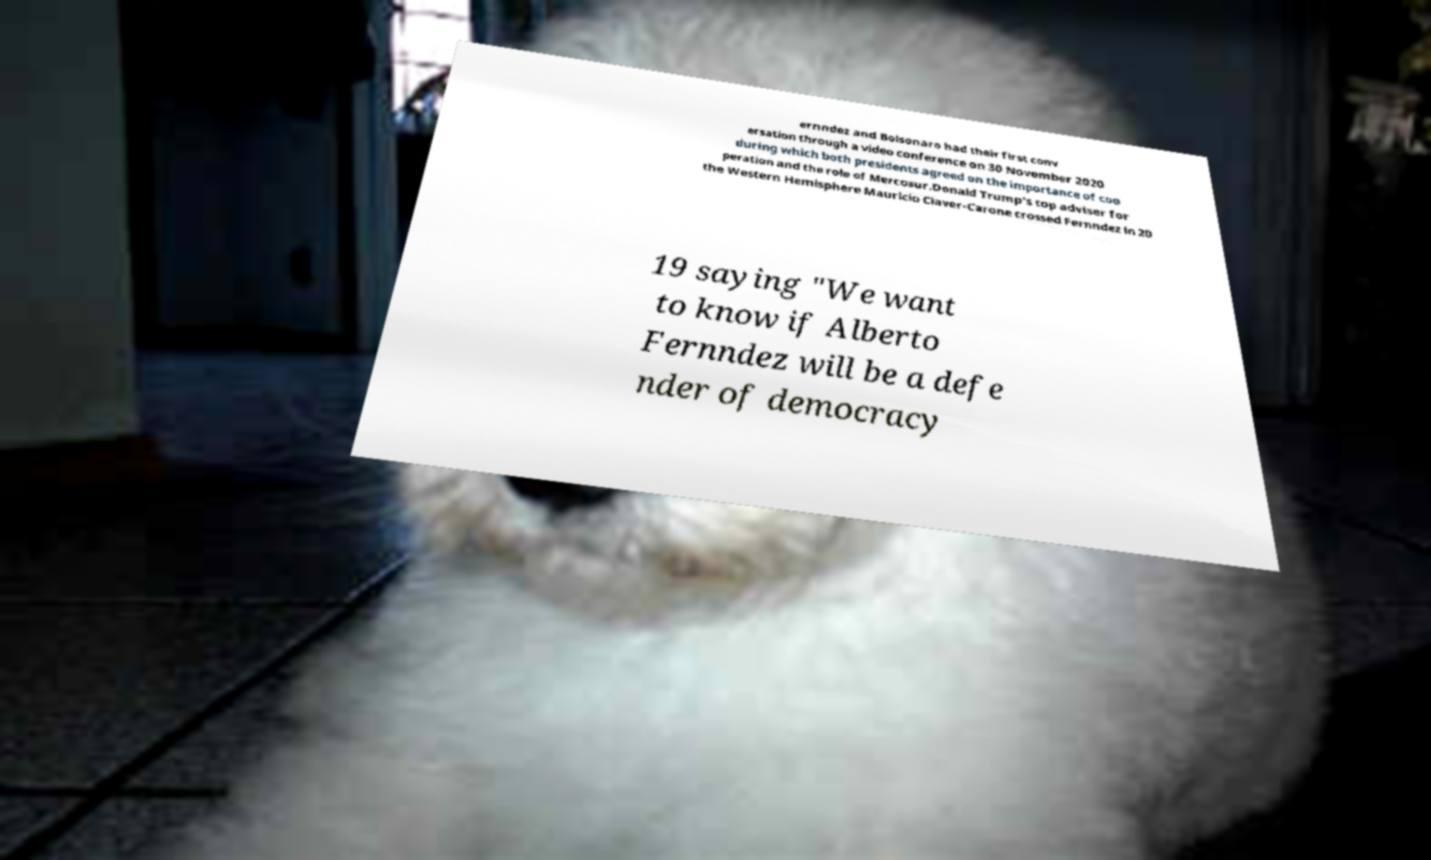Please identify and transcribe the text found in this image. ernndez and Bolsonaro had their first conv ersation through a video conference on 30 November 2020 during which both presidents agreed on the importance of coo peration and the role of Mercosur.Donald Trump's top adviser for the Western Hemisphere Mauricio Claver-Carone crossed Fernndez in 20 19 saying "We want to know if Alberto Fernndez will be a defe nder of democracy 